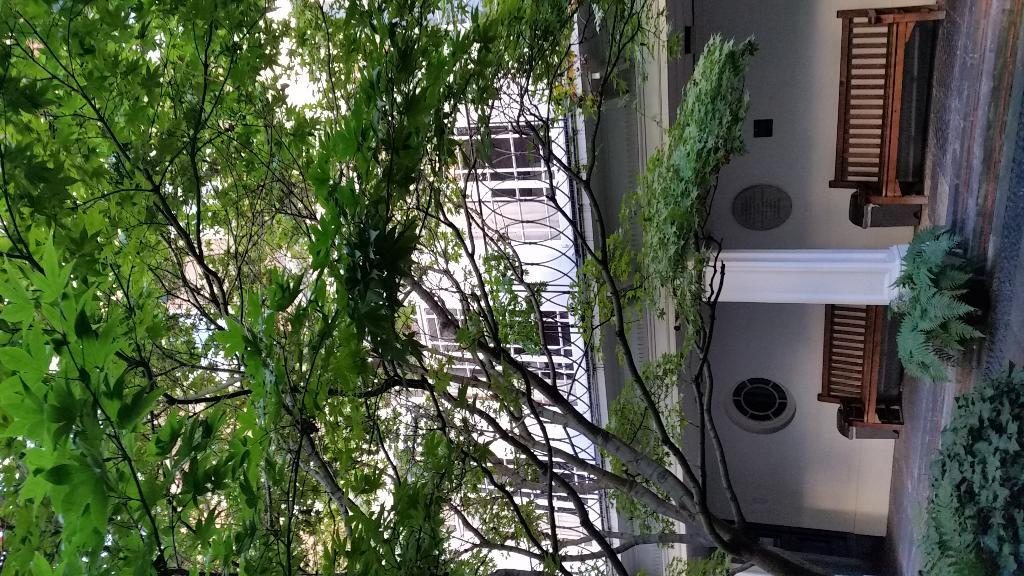What type of vegetation is on the left side of the image? There are trees on the left side of the image. What can be seen in the image that people might use for sitting? There are sitting bench chairs in the image. What type of structure is visible in the image? There is a building in the image. What is the color of the building in the image? The building is white in color. What is the rate of the story being told by the stem in the image? There is no story or stem present in the image. What type of stem can be seen growing from the building in the image? There is no stem present in the image, as it features trees, sitting bench chairs, and a white building. 